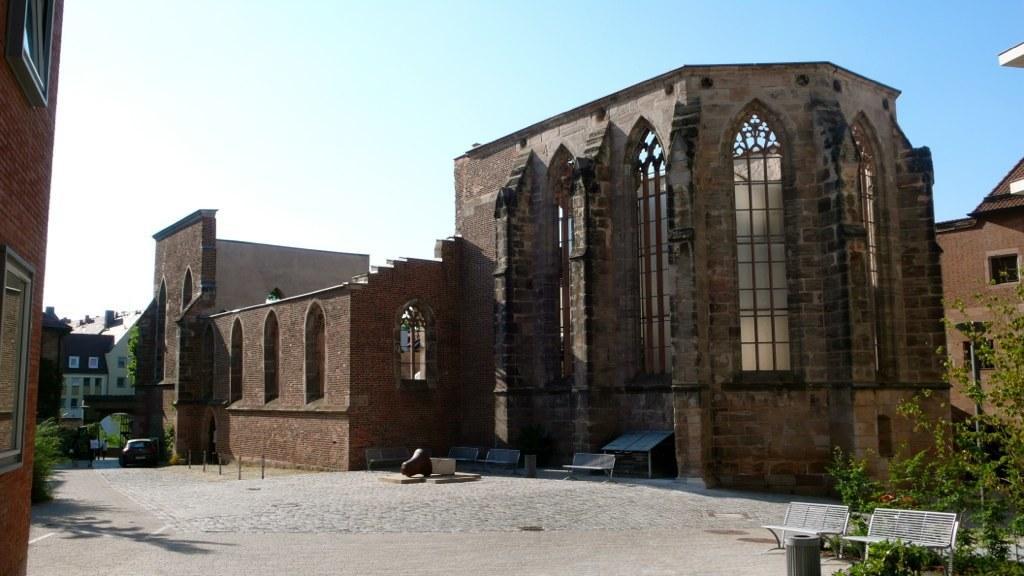Can you describe this image briefly? In the image in the center, we can see the sky, buildings, windows, trees, benches, one vehicle and a few other objects. 